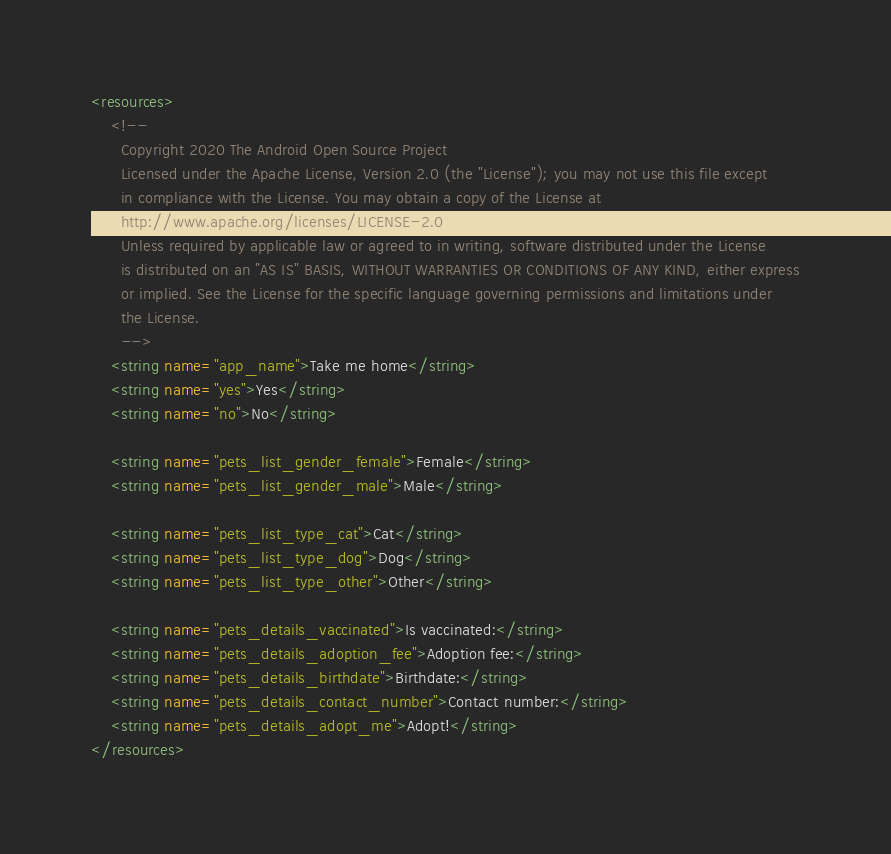<code> <loc_0><loc_0><loc_500><loc_500><_XML_><resources>
    <!--
      Copyright 2020 The Android Open Source Project
      Licensed under the Apache License, Version 2.0 (the "License"); you may not use this file except
      in compliance with the License. You may obtain a copy of the License at
      http://www.apache.org/licenses/LICENSE-2.0
      Unless required by applicable law or agreed to in writing, software distributed under the License
      is distributed on an "AS IS" BASIS, WITHOUT WARRANTIES OR CONDITIONS OF ANY KIND, either express
      or implied. See the License for the specific language governing permissions and limitations under
      the License.
      -->
    <string name="app_name">Take me home</string>
    <string name="yes">Yes</string>
    <string name="no">No</string>

    <string name="pets_list_gender_female">Female</string>
    <string name="pets_list_gender_male">Male</string>

    <string name="pets_list_type_cat">Cat</string>
    <string name="pets_list_type_dog">Dog</string>
    <string name="pets_list_type_other">Other</string>

    <string name="pets_details_vaccinated">Is vaccinated:</string>
    <string name="pets_details_adoption_fee">Adoption fee:</string>
    <string name="pets_details_birthdate">Birthdate:</string>
    <string name="pets_details_contact_number">Contact number:</string>
    <string name="pets_details_adopt_me">Adopt!</string>
</resources></code> 